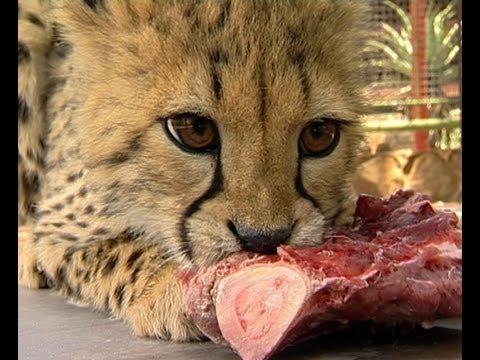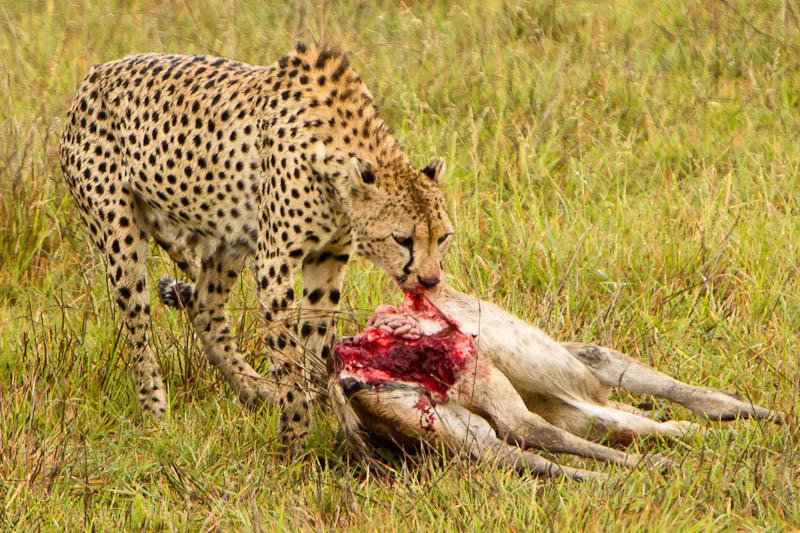The first image is the image on the left, the second image is the image on the right. Considering the images on both sides, is "In at least one image there is a dead elk will all four if its legs in front of a cheetah." valid? Answer yes or no. Yes. 